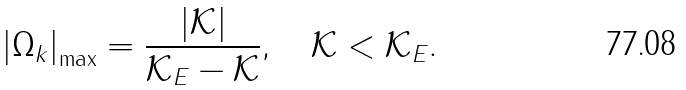<formula> <loc_0><loc_0><loc_500><loc_500>\left | \Omega _ { k } \right | _ { \max } = \frac { | \mathcal { K } | } { \mathcal { K } _ { E } - \mathcal { K } } , \quad \mathcal { K } < \mathcal { K } _ { E } .</formula> 